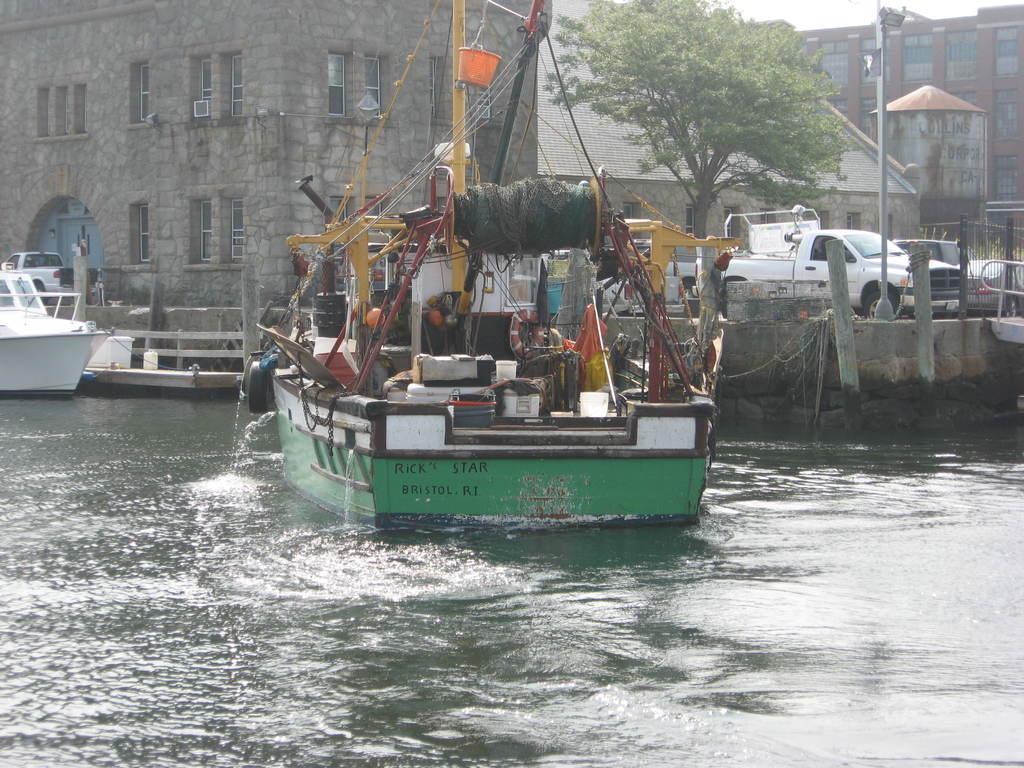Could you give a brief overview of what you see in this image? In this image at the bottom there is a sea, and in the sea there is a ship. In the ship there is an air balloon, flag, baskets, boxes, poles, buckets, rope and objects. On the left side there is another boat, in the background there are some vehicles, pillars, railing, building, trees, poles and plants. 